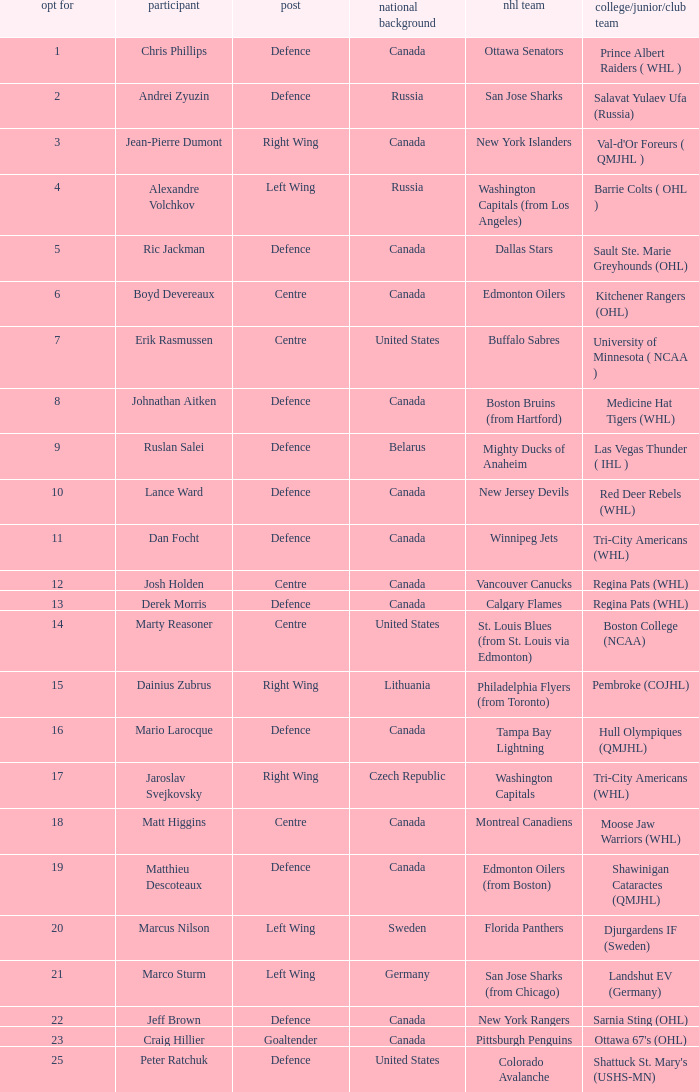How many positions does the draft pick whose nationality is Czech Republic play? 1.0. 